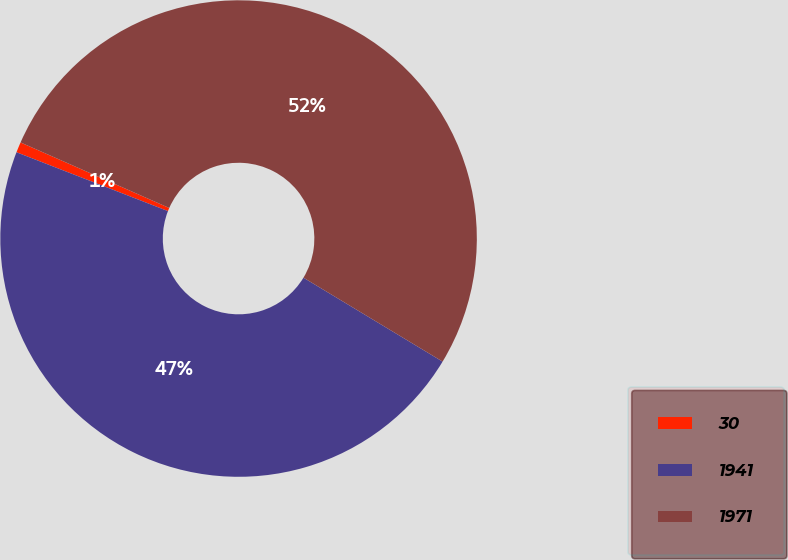Convert chart to OTSL. <chart><loc_0><loc_0><loc_500><loc_500><pie_chart><fcel>30<fcel>1941<fcel>1971<nl><fcel>0.71%<fcel>47.26%<fcel>52.03%<nl></chart> 